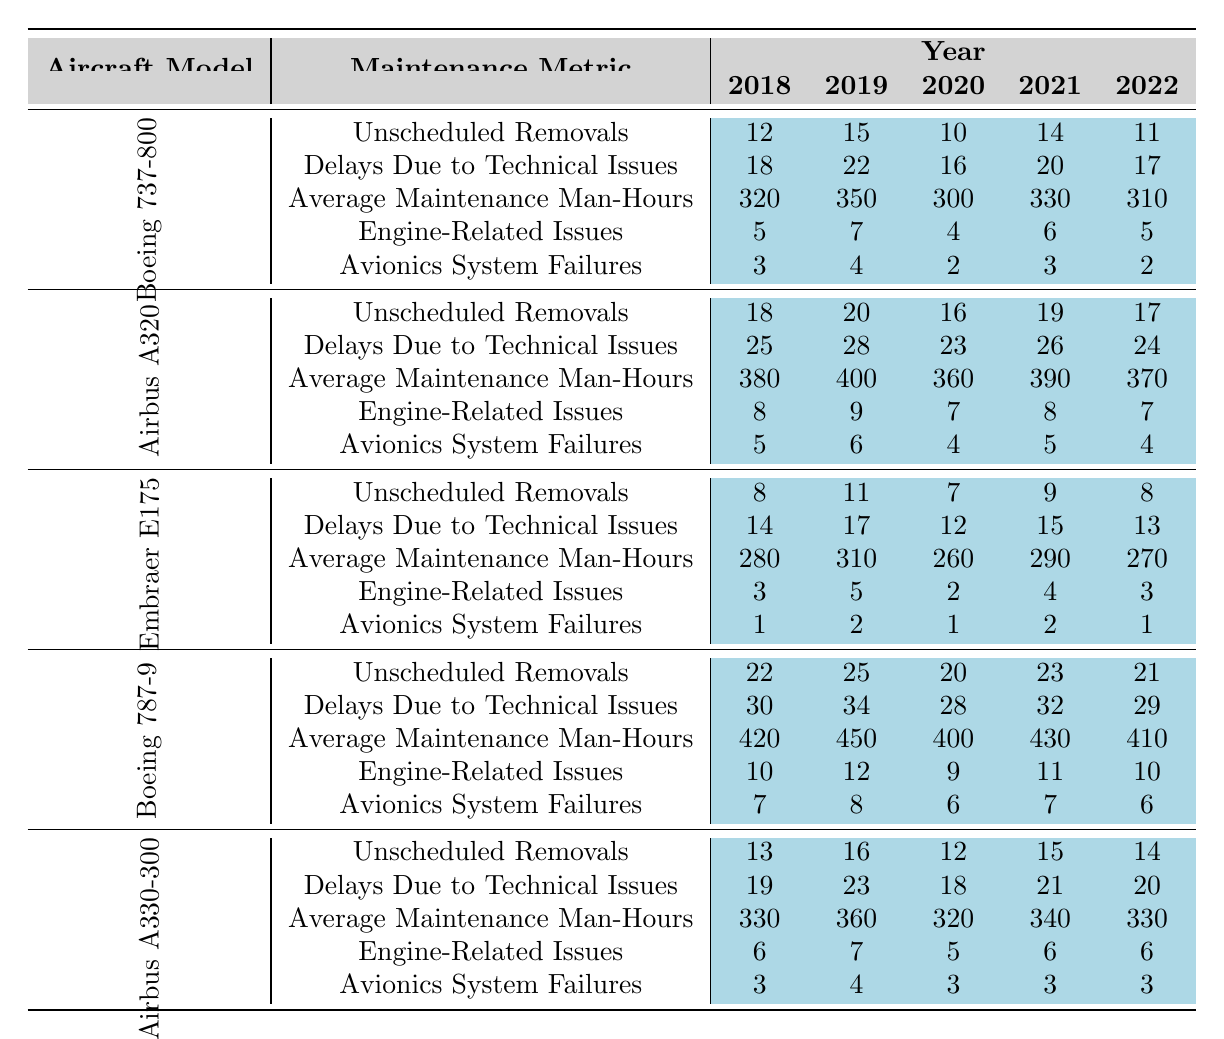What's the total number of unscheduled removals for the Boeing 737-800 from 2018 to 2022? By adding the values for unscheduled removals for the Boeing 737-800 over the years, we have 12 + 15 + 10 + 14 + 11 = 62.
Answer: 62 What was the average maintenance man-hours for the Airbus A320 over the five years? The maintenance man-hours for Airbus A320 over the years are 380, 400, 360, 390, and 370. Adding these gives 380 + 400 + 360 + 390 + 370 = 1900, and dividing by 5 gives an average of 1900 / 5 = 380.
Answer: 380 Did the Embraer E175 have more Engine-Related Issues in 2020 than in 2019? The Engine-Related Issues for Embraer E175 in 2019 is 5, and in 2020 it is 2. Since 5 is greater than 2, the statement is true.
Answer: Yes Which aircraft model had the highest total of Delays Due to Technical Issues over the five years? Summing Delays Due to Technical Issues for each aircraft gives: Boeing 737-800 (18+22+16+20+17=93), Airbus A320 (25+28+23+26+24=126), Embraer E175 (14+17+12+15+13=71), Boeing 787-9 (30+34+28+32+29=153), Airbus A330-300 (19+23+18+21+20=101). Boeing 787-9 has the highest total at 153.
Answer: Boeing 787-9 What was the trend in Avionics System Failures for the Airbus A330-300 over the years? The values for Avionics System Failures for Airbus A330-300 are 3, 4, 3, 3, 3. Noticing the pattern, the failures peaked at 4 in 2019 and then dropped to 3 for the following years. This indicates a decline in failures post-2019.
Answer: Decline after 2019 If we compare the total unscheduled removals of Boeing 787-9 and Airbus A320, which has more? Total for Boeing 787-9: 22 + 25 + 20 + 23 + 21 = 111. Total for Airbus A320: 18 + 20 + 16 + 19 + 17 = 90. Since 111 is greater than 90, the Boeing 787-9 has more unscheduled removals.
Answer: Boeing 787-9 What is the change in Average Maintenance Man-Hours for the Embraer E175 from 2018 to 2022? The Average Maintenance Man-Hours for Embraer E175 in 2018 is 280 and in 2022 it is 270. The change can be calculated as 270 - 280 = -10, indicating a decrease.
Answer: -10 Is the average for Delays Due to Technical Issues for Boeing 737-800 higher than that of Airbus A330-300? Average for Boeing 737-800: (18 + 22 + 16 + 20 + 17) / 5 = 18.6. Average for Airbus A330-300: (19 + 23 + 18 + 21 + 20) / 5 = 20.2. Since 18.6 is less than 20.2, the statement is false.
Answer: No What aircraft model had the lowest average Engine-Related Issues over the five years? Engine-Related Issues for the aircraft models are as follows: Boeing 737-800 (5, 7, 4, 6, 5), Airbus A320 (8, 9, 7, 8, 7), Embraer E175 (3, 5, 2, 4, 3), Boeing 787-9 (10, 12, 9, 11, 10), and Airbus A330-300 (6, 7, 5, 6, 6). The averages are calculated as follows: 5.4, 7.4, 3.4, 10.4, and 6.0. The lowest average is 3.4 for Embraer E175.
Answer: Embraer E175 What was the highest recorded value for Average Maintenance Man-Hours across all aircraft models in 2021? Reviewing the 2021 values: Boeing 737-800 (330), Airbus A320 (390), Embraer E175 (290), Boeing 787-9 (430), Airbus A330-300 (340). The highest value is 430 for Boeing 787-9.
Answer: Boeing 787-9 In which year did the Airbus A320 see the most significant drop in Average Maintenance Man-Hours compared to the previous year? Checking the changes: 2019 to 2018: 400 - 380 = 20, 2020 to 2019: 360 - 400 = -40, 2021 to 2020: 390 - 360 = 30, 2022 to 2021: 370 - 390 = -20. The most significant drop was from 2019 to 2020, a decrease of 40 hours.
Answer: 2020 